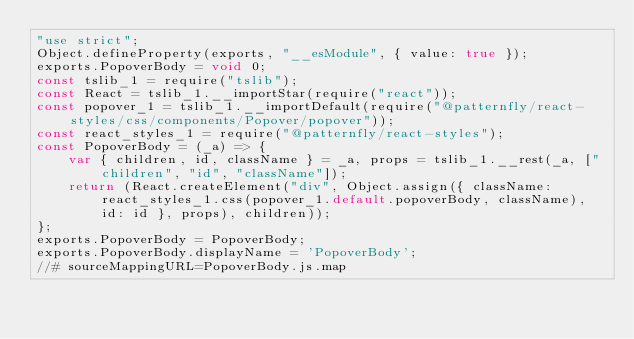Convert code to text. <code><loc_0><loc_0><loc_500><loc_500><_JavaScript_>"use strict";
Object.defineProperty(exports, "__esModule", { value: true });
exports.PopoverBody = void 0;
const tslib_1 = require("tslib");
const React = tslib_1.__importStar(require("react"));
const popover_1 = tslib_1.__importDefault(require("@patternfly/react-styles/css/components/Popover/popover"));
const react_styles_1 = require("@patternfly/react-styles");
const PopoverBody = (_a) => {
    var { children, id, className } = _a, props = tslib_1.__rest(_a, ["children", "id", "className"]);
    return (React.createElement("div", Object.assign({ className: react_styles_1.css(popover_1.default.popoverBody, className), id: id }, props), children));
};
exports.PopoverBody = PopoverBody;
exports.PopoverBody.displayName = 'PopoverBody';
//# sourceMappingURL=PopoverBody.js.map</code> 